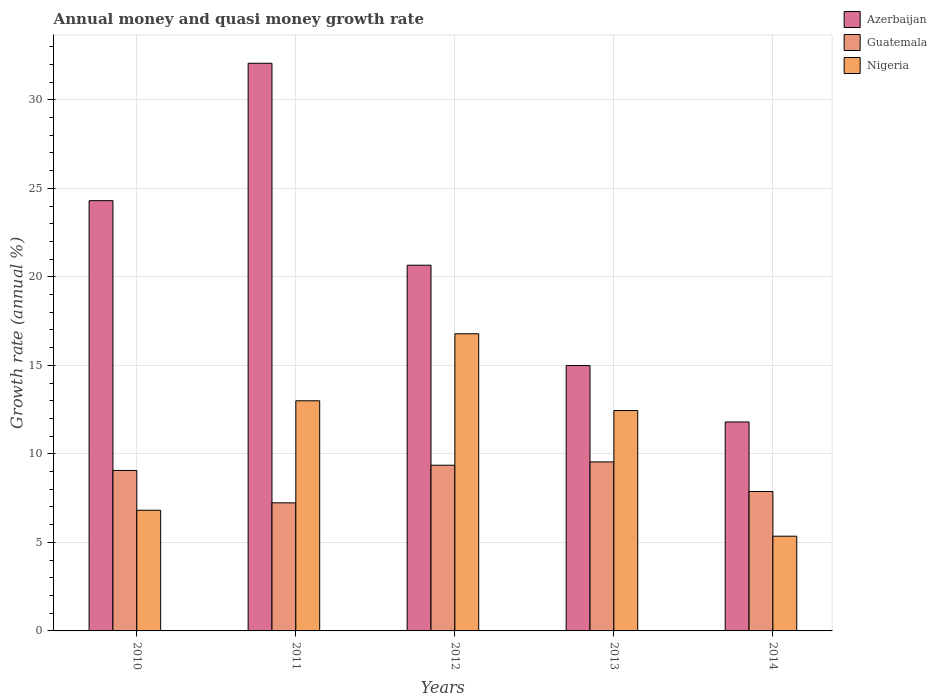Are the number of bars on each tick of the X-axis equal?
Provide a short and direct response. Yes. What is the growth rate in Nigeria in 2013?
Offer a very short reply. 12.45. Across all years, what is the maximum growth rate in Azerbaijan?
Your response must be concise. 32.07. Across all years, what is the minimum growth rate in Azerbaijan?
Offer a terse response. 11.8. In which year was the growth rate in Nigeria maximum?
Provide a short and direct response. 2012. In which year was the growth rate in Guatemala minimum?
Your answer should be very brief. 2011. What is the total growth rate in Guatemala in the graph?
Your answer should be very brief. 43.08. What is the difference between the growth rate in Guatemala in 2012 and that in 2013?
Your answer should be very brief. -0.19. What is the difference between the growth rate in Azerbaijan in 2011 and the growth rate in Guatemala in 2010?
Offer a very short reply. 23. What is the average growth rate in Nigeria per year?
Keep it short and to the point. 10.88. In the year 2010, what is the difference between the growth rate in Guatemala and growth rate in Azerbaijan?
Offer a very short reply. -15.24. In how many years, is the growth rate in Nigeria greater than 9 %?
Offer a very short reply. 3. What is the ratio of the growth rate in Guatemala in 2011 to that in 2013?
Ensure brevity in your answer.  0.76. What is the difference between the highest and the second highest growth rate in Guatemala?
Make the answer very short. 0.19. What is the difference between the highest and the lowest growth rate in Azerbaijan?
Offer a terse response. 20.26. Is the sum of the growth rate in Azerbaijan in 2010 and 2012 greater than the maximum growth rate in Nigeria across all years?
Offer a terse response. Yes. What does the 1st bar from the left in 2013 represents?
Keep it short and to the point. Azerbaijan. What does the 3rd bar from the right in 2013 represents?
Offer a terse response. Azerbaijan. How many bars are there?
Your answer should be compact. 15. Are all the bars in the graph horizontal?
Keep it short and to the point. No. How many years are there in the graph?
Provide a succinct answer. 5. Are the values on the major ticks of Y-axis written in scientific E-notation?
Offer a terse response. No. Does the graph contain grids?
Offer a terse response. Yes. How many legend labels are there?
Your answer should be compact. 3. What is the title of the graph?
Your response must be concise. Annual money and quasi money growth rate. What is the label or title of the Y-axis?
Make the answer very short. Growth rate (annual %). What is the Growth rate (annual %) in Azerbaijan in 2010?
Give a very brief answer. 24.3. What is the Growth rate (annual %) in Guatemala in 2010?
Offer a very short reply. 9.06. What is the Growth rate (annual %) of Nigeria in 2010?
Your response must be concise. 6.82. What is the Growth rate (annual %) in Azerbaijan in 2011?
Your answer should be very brief. 32.07. What is the Growth rate (annual %) in Guatemala in 2011?
Offer a very short reply. 7.23. What is the Growth rate (annual %) of Nigeria in 2011?
Offer a very short reply. 13. What is the Growth rate (annual %) of Azerbaijan in 2012?
Offer a terse response. 20.66. What is the Growth rate (annual %) in Guatemala in 2012?
Provide a short and direct response. 9.36. What is the Growth rate (annual %) in Nigeria in 2012?
Ensure brevity in your answer.  16.79. What is the Growth rate (annual %) in Azerbaijan in 2013?
Keep it short and to the point. 14.99. What is the Growth rate (annual %) in Guatemala in 2013?
Keep it short and to the point. 9.55. What is the Growth rate (annual %) in Nigeria in 2013?
Ensure brevity in your answer.  12.45. What is the Growth rate (annual %) of Azerbaijan in 2014?
Provide a short and direct response. 11.8. What is the Growth rate (annual %) in Guatemala in 2014?
Offer a very short reply. 7.87. What is the Growth rate (annual %) in Nigeria in 2014?
Your answer should be very brief. 5.35. Across all years, what is the maximum Growth rate (annual %) of Azerbaijan?
Offer a terse response. 32.07. Across all years, what is the maximum Growth rate (annual %) in Guatemala?
Your response must be concise. 9.55. Across all years, what is the maximum Growth rate (annual %) in Nigeria?
Give a very brief answer. 16.79. Across all years, what is the minimum Growth rate (annual %) in Azerbaijan?
Ensure brevity in your answer.  11.8. Across all years, what is the minimum Growth rate (annual %) in Guatemala?
Keep it short and to the point. 7.23. Across all years, what is the minimum Growth rate (annual %) of Nigeria?
Your answer should be very brief. 5.35. What is the total Growth rate (annual %) of Azerbaijan in the graph?
Give a very brief answer. 103.82. What is the total Growth rate (annual %) of Guatemala in the graph?
Ensure brevity in your answer.  43.08. What is the total Growth rate (annual %) in Nigeria in the graph?
Give a very brief answer. 54.4. What is the difference between the Growth rate (annual %) of Azerbaijan in 2010 and that in 2011?
Ensure brevity in your answer.  -7.76. What is the difference between the Growth rate (annual %) of Guatemala in 2010 and that in 2011?
Offer a terse response. 1.83. What is the difference between the Growth rate (annual %) in Nigeria in 2010 and that in 2011?
Offer a very short reply. -6.18. What is the difference between the Growth rate (annual %) in Azerbaijan in 2010 and that in 2012?
Ensure brevity in your answer.  3.65. What is the difference between the Growth rate (annual %) in Guatemala in 2010 and that in 2012?
Make the answer very short. -0.3. What is the difference between the Growth rate (annual %) in Nigeria in 2010 and that in 2012?
Make the answer very short. -9.97. What is the difference between the Growth rate (annual %) in Azerbaijan in 2010 and that in 2013?
Your answer should be very brief. 9.31. What is the difference between the Growth rate (annual %) in Guatemala in 2010 and that in 2013?
Ensure brevity in your answer.  -0.48. What is the difference between the Growth rate (annual %) in Nigeria in 2010 and that in 2013?
Keep it short and to the point. -5.63. What is the difference between the Growth rate (annual %) of Azerbaijan in 2010 and that in 2014?
Give a very brief answer. 12.5. What is the difference between the Growth rate (annual %) in Guatemala in 2010 and that in 2014?
Offer a terse response. 1.19. What is the difference between the Growth rate (annual %) in Nigeria in 2010 and that in 2014?
Keep it short and to the point. 1.47. What is the difference between the Growth rate (annual %) in Azerbaijan in 2011 and that in 2012?
Your answer should be very brief. 11.41. What is the difference between the Growth rate (annual %) of Guatemala in 2011 and that in 2012?
Keep it short and to the point. -2.13. What is the difference between the Growth rate (annual %) in Nigeria in 2011 and that in 2012?
Your response must be concise. -3.79. What is the difference between the Growth rate (annual %) of Azerbaijan in 2011 and that in 2013?
Ensure brevity in your answer.  17.08. What is the difference between the Growth rate (annual %) of Guatemala in 2011 and that in 2013?
Your answer should be compact. -2.31. What is the difference between the Growth rate (annual %) of Nigeria in 2011 and that in 2013?
Make the answer very short. 0.55. What is the difference between the Growth rate (annual %) in Azerbaijan in 2011 and that in 2014?
Keep it short and to the point. 20.26. What is the difference between the Growth rate (annual %) in Guatemala in 2011 and that in 2014?
Give a very brief answer. -0.64. What is the difference between the Growth rate (annual %) of Nigeria in 2011 and that in 2014?
Your answer should be compact. 7.65. What is the difference between the Growth rate (annual %) in Azerbaijan in 2012 and that in 2013?
Give a very brief answer. 5.67. What is the difference between the Growth rate (annual %) of Guatemala in 2012 and that in 2013?
Make the answer very short. -0.19. What is the difference between the Growth rate (annual %) in Nigeria in 2012 and that in 2013?
Your response must be concise. 4.34. What is the difference between the Growth rate (annual %) of Azerbaijan in 2012 and that in 2014?
Your response must be concise. 8.86. What is the difference between the Growth rate (annual %) in Guatemala in 2012 and that in 2014?
Your answer should be very brief. 1.49. What is the difference between the Growth rate (annual %) of Nigeria in 2012 and that in 2014?
Make the answer very short. 11.44. What is the difference between the Growth rate (annual %) of Azerbaijan in 2013 and that in 2014?
Keep it short and to the point. 3.19. What is the difference between the Growth rate (annual %) in Guatemala in 2013 and that in 2014?
Your response must be concise. 1.67. What is the difference between the Growth rate (annual %) of Nigeria in 2013 and that in 2014?
Your response must be concise. 7.1. What is the difference between the Growth rate (annual %) in Azerbaijan in 2010 and the Growth rate (annual %) in Guatemala in 2011?
Ensure brevity in your answer.  17.07. What is the difference between the Growth rate (annual %) in Azerbaijan in 2010 and the Growth rate (annual %) in Nigeria in 2011?
Offer a terse response. 11.3. What is the difference between the Growth rate (annual %) of Guatemala in 2010 and the Growth rate (annual %) of Nigeria in 2011?
Your response must be concise. -3.93. What is the difference between the Growth rate (annual %) of Azerbaijan in 2010 and the Growth rate (annual %) of Guatemala in 2012?
Offer a very short reply. 14.94. What is the difference between the Growth rate (annual %) of Azerbaijan in 2010 and the Growth rate (annual %) of Nigeria in 2012?
Ensure brevity in your answer.  7.52. What is the difference between the Growth rate (annual %) of Guatemala in 2010 and the Growth rate (annual %) of Nigeria in 2012?
Offer a terse response. -7.72. What is the difference between the Growth rate (annual %) of Azerbaijan in 2010 and the Growth rate (annual %) of Guatemala in 2013?
Your answer should be compact. 14.76. What is the difference between the Growth rate (annual %) in Azerbaijan in 2010 and the Growth rate (annual %) in Nigeria in 2013?
Your answer should be compact. 11.85. What is the difference between the Growth rate (annual %) in Guatemala in 2010 and the Growth rate (annual %) in Nigeria in 2013?
Provide a short and direct response. -3.39. What is the difference between the Growth rate (annual %) in Azerbaijan in 2010 and the Growth rate (annual %) in Guatemala in 2014?
Ensure brevity in your answer.  16.43. What is the difference between the Growth rate (annual %) in Azerbaijan in 2010 and the Growth rate (annual %) in Nigeria in 2014?
Your answer should be very brief. 18.95. What is the difference between the Growth rate (annual %) of Guatemala in 2010 and the Growth rate (annual %) of Nigeria in 2014?
Ensure brevity in your answer.  3.71. What is the difference between the Growth rate (annual %) of Azerbaijan in 2011 and the Growth rate (annual %) of Guatemala in 2012?
Offer a terse response. 22.7. What is the difference between the Growth rate (annual %) of Azerbaijan in 2011 and the Growth rate (annual %) of Nigeria in 2012?
Your answer should be compact. 15.28. What is the difference between the Growth rate (annual %) of Guatemala in 2011 and the Growth rate (annual %) of Nigeria in 2012?
Give a very brief answer. -9.55. What is the difference between the Growth rate (annual %) in Azerbaijan in 2011 and the Growth rate (annual %) in Guatemala in 2013?
Provide a succinct answer. 22.52. What is the difference between the Growth rate (annual %) of Azerbaijan in 2011 and the Growth rate (annual %) of Nigeria in 2013?
Provide a succinct answer. 19.62. What is the difference between the Growth rate (annual %) in Guatemala in 2011 and the Growth rate (annual %) in Nigeria in 2013?
Offer a very short reply. -5.21. What is the difference between the Growth rate (annual %) in Azerbaijan in 2011 and the Growth rate (annual %) in Guatemala in 2014?
Provide a succinct answer. 24.19. What is the difference between the Growth rate (annual %) of Azerbaijan in 2011 and the Growth rate (annual %) of Nigeria in 2014?
Make the answer very short. 26.71. What is the difference between the Growth rate (annual %) in Guatemala in 2011 and the Growth rate (annual %) in Nigeria in 2014?
Provide a succinct answer. 1.88. What is the difference between the Growth rate (annual %) in Azerbaijan in 2012 and the Growth rate (annual %) in Guatemala in 2013?
Offer a terse response. 11.11. What is the difference between the Growth rate (annual %) of Azerbaijan in 2012 and the Growth rate (annual %) of Nigeria in 2013?
Keep it short and to the point. 8.21. What is the difference between the Growth rate (annual %) in Guatemala in 2012 and the Growth rate (annual %) in Nigeria in 2013?
Your answer should be compact. -3.09. What is the difference between the Growth rate (annual %) of Azerbaijan in 2012 and the Growth rate (annual %) of Guatemala in 2014?
Offer a very short reply. 12.78. What is the difference between the Growth rate (annual %) in Azerbaijan in 2012 and the Growth rate (annual %) in Nigeria in 2014?
Your answer should be very brief. 15.31. What is the difference between the Growth rate (annual %) in Guatemala in 2012 and the Growth rate (annual %) in Nigeria in 2014?
Provide a succinct answer. 4.01. What is the difference between the Growth rate (annual %) in Azerbaijan in 2013 and the Growth rate (annual %) in Guatemala in 2014?
Make the answer very short. 7.11. What is the difference between the Growth rate (annual %) of Azerbaijan in 2013 and the Growth rate (annual %) of Nigeria in 2014?
Give a very brief answer. 9.64. What is the difference between the Growth rate (annual %) of Guatemala in 2013 and the Growth rate (annual %) of Nigeria in 2014?
Ensure brevity in your answer.  4.2. What is the average Growth rate (annual %) in Azerbaijan per year?
Offer a very short reply. 20.76. What is the average Growth rate (annual %) of Guatemala per year?
Provide a short and direct response. 8.62. What is the average Growth rate (annual %) in Nigeria per year?
Your answer should be compact. 10.88. In the year 2010, what is the difference between the Growth rate (annual %) of Azerbaijan and Growth rate (annual %) of Guatemala?
Ensure brevity in your answer.  15.24. In the year 2010, what is the difference between the Growth rate (annual %) of Azerbaijan and Growth rate (annual %) of Nigeria?
Offer a terse response. 17.49. In the year 2010, what is the difference between the Growth rate (annual %) of Guatemala and Growth rate (annual %) of Nigeria?
Make the answer very short. 2.25. In the year 2011, what is the difference between the Growth rate (annual %) in Azerbaijan and Growth rate (annual %) in Guatemala?
Provide a succinct answer. 24.83. In the year 2011, what is the difference between the Growth rate (annual %) of Azerbaijan and Growth rate (annual %) of Nigeria?
Offer a very short reply. 19.07. In the year 2011, what is the difference between the Growth rate (annual %) of Guatemala and Growth rate (annual %) of Nigeria?
Give a very brief answer. -5.76. In the year 2012, what is the difference between the Growth rate (annual %) of Azerbaijan and Growth rate (annual %) of Guatemala?
Make the answer very short. 11.3. In the year 2012, what is the difference between the Growth rate (annual %) in Azerbaijan and Growth rate (annual %) in Nigeria?
Give a very brief answer. 3.87. In the year 2012, what is the difference between the Growth rate (annual %) in Guatemala and Growth rate (annual %) in Nigeria?
Offer a very short reply. -7.43. In the year 2013, what is the difference between the Growth rate (annual %) in Azerbaijan and Growth rate (annual %) in Guatemala?
Provide a succinct answer. 5.44. In the year 2013, what is the difference between the Growth rate (annual %) in Azerbaijan and Growth rate (annual %) in Nigeria?
Give a very brief answer. 2.54. In the year 2013, what is the difference between the Growth rate (annual %) of Guatemala and Growth rate (annual %) of Nigeria?
Your response must be concise. -2.9. In the year 2014, what is the difference between the Growth rate (annual %) in Azerbaijan and Growth rate (annual %) in Guatemala?
Your answer should be compact. 3.93. In the year 2014, what is the difference between the Growth rate (annual %) in Azerbaijan and Growth rate (annual %) in Nigeria?
Offer a terse response. 6.45. In the year 2014, what is the difference between the Growth rate (annual %) in Guatemala and Growth rate (annual %) in Nigeria?
Provide a short and direct response. 2.52. What is the ratio of the Growth rate (annual %) of Azerbaijan in 2010 to that in 2011?
Provide a short and direct response. 0.76. What is the ratio of the Growth rate (annual %) of Guatemala in 2010 to that in 2011?
Keep it short and to the point. 1.25. What is the ratio of the Growth rate (annual %) of Nigeria in 2010 to that in 2011?
Provide a succinct answer. 0.52. What is the ratio of the Growth rate (annual %) in Azerbaijan in 2010 to that in 2012?
Your answer should be compact. 1.18. What is the ratio of the Growth rate (annual %) in Guatemala in 2010 to that in 2012?
Offer a terse response. 0.97. What is the ratio of the Growth rate (annual %) in Nigeria in 2010 to that in 2012?
Offer a very short reply. 0.41. What is the ratio of the Growth rate (annual %) of Azerbaijan in 2010 to that in 2013?
Ensure brevity in your answer.  1.62. What is the ratio of the Growth rate (annual %) in Guatemala in 2010 to that in 2013?
Your response must be concise. 0.95. What is the ratio of the Growth rate (annual %) of Nigeria in 2010 to that in 2013?
Offer a very short reply. 0.55. What is the ratio of the Growth rate (annual %) of Azerbaijan in 2010 to that in 2014?
Your answer should be very brief. 2.06. What is the ratio of the Growth rate (annual %) of Guatemala in 2010 to that in 2014?
Provide a short and direct response. 1.15. What is the ratio of the Growth rate (annual %) in Nigeria in 2010 to that in 2014?
Provide a succinct answer. 1.27. What is the ratio of the Growth rate (annual %) in Azerbaijan in 2011 to that in 2012?
Your answer should be compact. 1.55. What is the ratio of the Growth rate (annual %) in Guatemala in 2011 to that in 2012?
Provide a succinct answer. 0.77. What is the ratio of the Growth rate (annual %) of Nigeria in 2011 to that in 2012?
Offer a terse response. 0.77. What is the ratio of the Growth rate (annual %) of Azerbaijan in 2011 to that in 2013?
Ensure brevity in your answer.  2.14. What is the ratio of the Growth rate (annual %) in Guatemala in 2011 to that in 2013?
Give a very brief answer. 0.76. What is the ratio of the Growth rate (annual %) of Nigeria in 2011 to that in 2013?
Ensure brevity in your answer.  1.04. What is the ratio of the Growth rate (annual %) of Azerbaijan in 2011 to that in 2014?
Offer a very short reply. 2.72. What is the ratio of the Growth rate (annual %) in Guatemala in 2011 to that in 2014?
Ensure brevity in your answer.  0.92. What is the ratio of the Growth rate (annual %) in Nigeria in 2011 to that in 2014?
Provide a short and direct response. 2.43. What is the ratio of the Growth rate (annual %) of Azerbaijan in 2012 to that in 2013?
Offer a terse response. 1.38. What is the ratio of the Growth rate (annual %) of Guatemala in 2012 to that in 2013?
Offer a very short reply. 0.98. What is the ratio of the Growth rate (annual %) of Nigeria in 2012 to that in 2013?
Offer a terse response. 1.35. What is the ratio of the Growth rate (annual %) in Azerbaijan in 2012 to that in 2014?
Keep it short and to the point. 1.75. What is the ratio of the Growth rate (annual %) of Guatemala in 2012 to that in 2014?
Provide a short and direct response. 1.19. What is the ratio of the Growth rate (annual %) of Nigeria in 2012 to that in 2014?
Make the answer very short. 3.14. What is the ratio of the Growth rate (annual %) in Azerbaijan in 2013 to that in 2014?
Offer a very short reply. 1.27. What is the ratio of the Growth rate (annual %) of Guatemala in 2013 to that in 2014?
Provide a short and direct response. 1.21. What is the ratio of the Growth rate (annual %) in Nigeria in 2013 to that in 2014?
Your response must be concise. 2.33. What is the difference between the highest and the second highest Growth rate (annual %) of Azerbaijan?
Make the answer very short. 7.76. What is the difference between the highest and the second highest Growth rate (annual %) of Guatemala?
Ensure brevity in your answer.  0.19. What is the difference between the highest and the second highest Growth rate (annual %) in Nigeria?
Your answer should be very brief. 3.79. What is the difference between the highest and the lowest Growth rate (annual %) of Azerbaijan?
Your answer should be very brief. 20.26. What is the difference between the highest and the lowest Growth rate (annual %) of Guatemala?
Ensure brevity in your answer.  2.31. What is the difference between the highest and the lowest Growth rate (annual %) in Nigeria?
Ensure brevity in your answer.  11.44. 